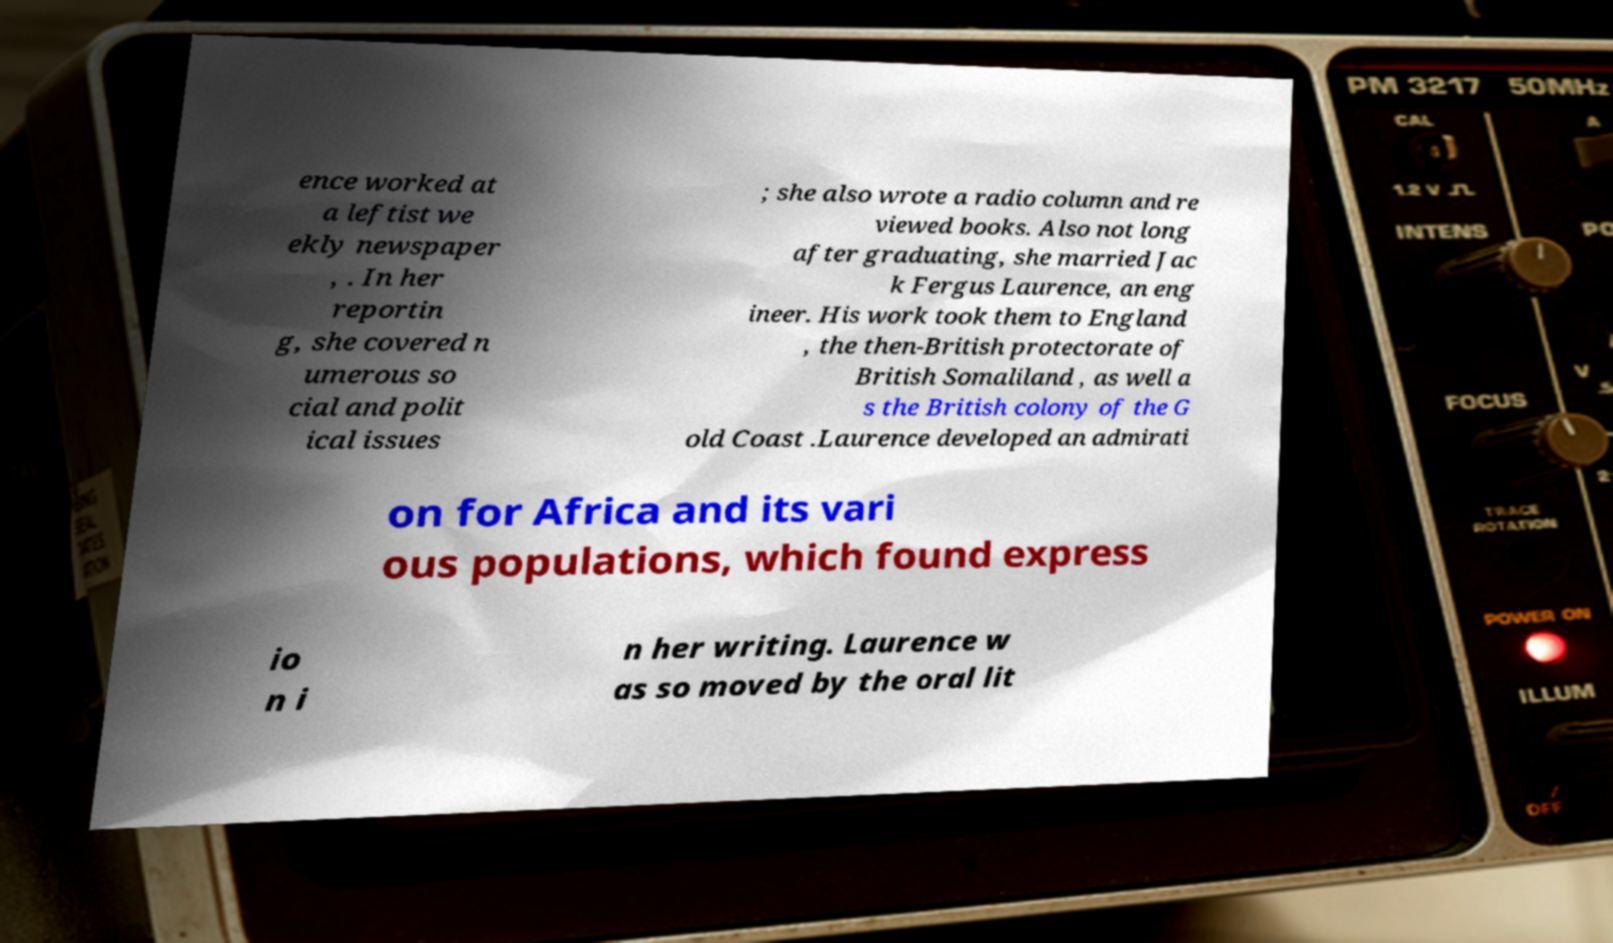For documentation purposes, I need the text within this image transcribed. Could you provide that? ence worked at a leftist we ekly newspaper , . In her reportin g, she covered n umerous so cial and polit ical issues ; she also wrote a radio column and re viewed books. Also not long after graduating, she married Jac k Fergus Laurence, an eng ineer. His work took them to England , the then-British protectorate of British Somaliland , as well a s the British colony of the G old Coast .Laurence developed an admirati on for Africa and its vari ous populations, which found express io n i n her writing. Laurence w as so moved by the oral lit 